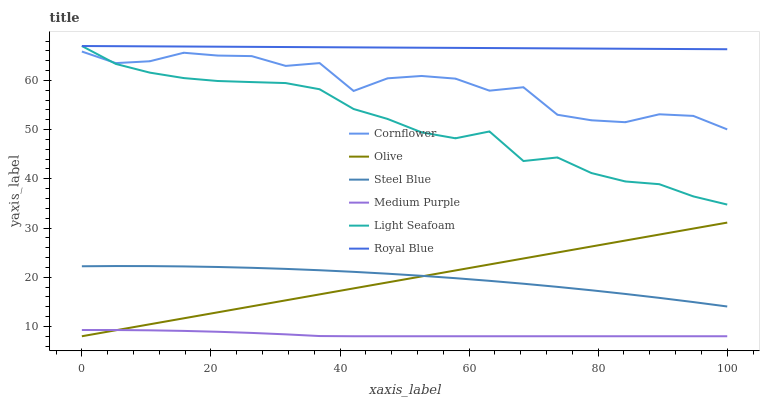Does Medium Purple have the minimum area under the curve?
Answer yes or no. Yes. Does Royal Blue have the maximum area under the curve?
Answer yes or no. Yes. Does Steel Blue have the minimum area under the curve?
Answer yes or no. No. Does Steel Blue have the maximum area under the curve?
Answer yes or no. No. Is Olive the smoothest?
Answer yes or no. Yes. Is Cornflower the roughest?
Answer yes or no. Yes. Is Steel Blue the smoothest?
Answer yes or no. No. Is Steel Blue the roughest?
Answer yes or no. No. Does Medium Purple have the lowest value?
Answer yes or no. Yes. Does Steel Blue have the lowest value?
Answer yes or no. No. Does Light Seafoam have the highest value?
Answer yes or no. Yes. Does Steel Blue have the highest value?
Answer yes or no. No. Is Steel Blue less than Cornflower?
Answer yes or no. Yes. Is Light Seafoam greater than Olive?
Answer yes or no. Yes. Does Steel Blue intersect Olive?
Answer yes or no. Yes. Is Steel Blue less than Olive?
Answer yes or no. No. Is Steel Blue greater than Olive?
Answer yes or no. No. Does Steel Blue intersect Cornflower?
Answer yes or no. No. 